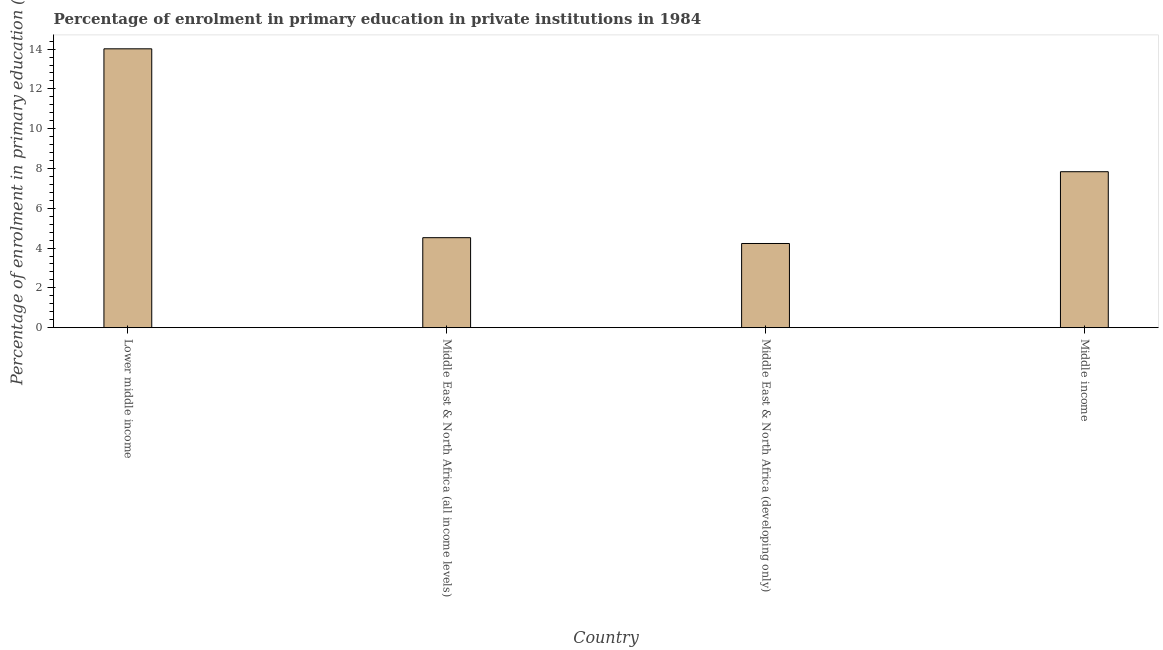What is the title of the graph?
Your answer should be compact. Percentage of enrolment in primary education in private institutions in 1984. What is the label or title of the X-axis?
Your answer should be compact. Country. What is the label or title of the Y-axis?
Offer a terse response. Percentage of enrolment in primary education (%). What is the enrolment percentage in primary education in Lower middle income?
Provide a succinct answer. 14.01. Across all countries, what is the maximum enrolment percentage in primary education?
Ensure brevity in your answer.  14.01. Across all countries, what is the minimum enrolment percentage in primary education?
Keep it short and to the point. 4.23. In which country was the enrolment percentage in primary education maximum?
Give a very brief answer. Lower middle income. In which country was the enrolment percentage in primary education minimum?
Your answer should be compact. Middle East & North Africa (developing only). What is the sum of the enrolment percentage in primary education?
Make the answer very short. 30.6. What is the difference between the enrolment percentage in primary education in Middle East & North Africa (all income levels) and Middle income?
Your response must be concise. -3.32. What is the average enrolment percentage in primary education per country?
Your response must be concise. 7.65. What is the median enrolment percentage in primary education?
Give a very brief answer. 6.18. In how many countries, is the enrolment percentage in primary education greater than 4 %?
Offer a very short reply. 4. What is the ratio of the enrolment percentage in primary education in Middle East & North Africa (all income levels) to that in Middle East & North Africa (developing only)?
Provide a succinct answer. 1.07. What is the difference between the highest and the second highest enrolment percentage in primary education?
Provide a short and direct response. 6.18. What is the difference between the highest and the lowest enrolment percentage in primary education?
Ensure brevity in your answer.  9.78. How many bars are there?
Your response must be concise. 4. Are all the bars in the graph horizontal?
Offer a very short reply. No. What is the difference between two consecutive major ticks on the Y-axis?
Provide a succinct answer. 2. Are the values on the major ticks of Y-axis written in scientific E-notation?
Make the answer very short. No. What is the Percentage of enrolment in primary education (%) in Lower middle income?
Keep it short and to the point. 14.01. What is the Percentage of enrolment in primary education (%) in Middle East & North Africa (all income levels)?
Ensure brevity in your answer.  4.52. What is the Percentage of enrolment in primary education (%) in Middle East & North Africa (developing only)?
Your answer should be very brief. 4.23. What is the Percentage of enrolment in primary education (%) of Middle income?
Ensure brevity in your answer.  7.84. What is the difference between the Percentage of enrolment in primary education (%) in Lower middle income and Middle East & North Africa (all income levels)?
Give a very brief answer. 9.49. What is the difference between the Percentage of enrolment in primary education (%) in Lower middle income and Middle East & North Africa (developing only)?
Your answer should be very brief. 9.78. What is the difference between the Percentage of enrolment in primary education (%) in Lower middle income and Middle income?
Offer a very short reply. 6.18. What is the difference between the Percentage of enrolment in primary education (%) in Middle East & North Africa (all income levels) and Middle East & North Africa (developing only)?
Provide a succinct answer. 0.29. What is the difference between the Percentage of enrolment in primary education (%) in Middle East & North Africa (all income levels) and Middle income?
Ensure brevity in your answer.  -3.32. What is the difference between the Percentage of enrolment in primary education (%) in Middle East & North Africa (developing only) and Middle income?
Make the answer very short. -3.61. What is the ratio of the Percentage of enrolment in primary education (%) in Lower middle income to that in Middle East & North Africa (all income levels)?
Offer a terse response. 3.1. What is the ratio of the Percentage of enrolment in primary education (%) in Lower middle income to that in Middle East & North Africa (developing only)?
Keep it short and to the point. 3.31. What is the ratio of the Percentage of enrolment in primary education (%) in Lower middle income to that in Middle income?
Provide a short and direct response. 1.79. What is the ratio of the Percentage of enrolment in primary education (%) in Middle East & North Africa (all income levels) to that in Middle East & North Africa (developing only)?
Offer a terse response. 1.07. What is the ratio of the Percentage of enrolment in primary education (%) in Middle East & North Africa (all income levels) to that in Middle income?
Offer a very short reply. 0.58. What is the ratio of the Percentage of enrolment in primary education (%) in Middle East & North Africa (developing only) to that in Middle income?
Offer a terse response. 0.54. 